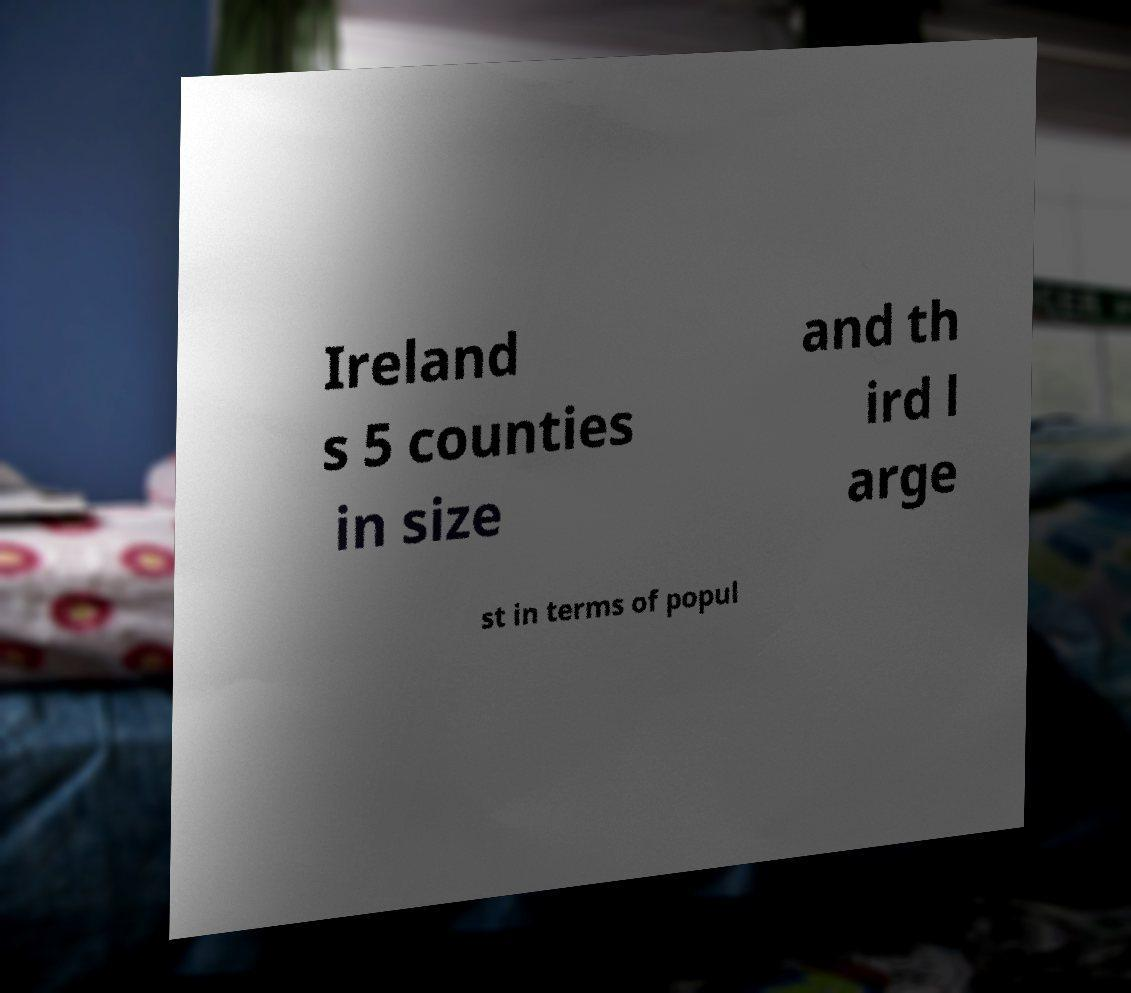Could you assist in decoding the text presented in this image and type it out clearly? Ireland s 5 counties in size and th ird l arge st in terms of popul 